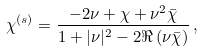<formula> <loc_0><loc_0><loc_500><loc_500>\chi ^ { \left ( s \right ) } = \frac { - 2 \nu + \chi + \nu ^ { 2 } \bar { \chi } } { 1 + | \nu | ^ { 2 } - 2 \Re \left ( \nu \bar { \chi } \right ) } \, ,</formula> 